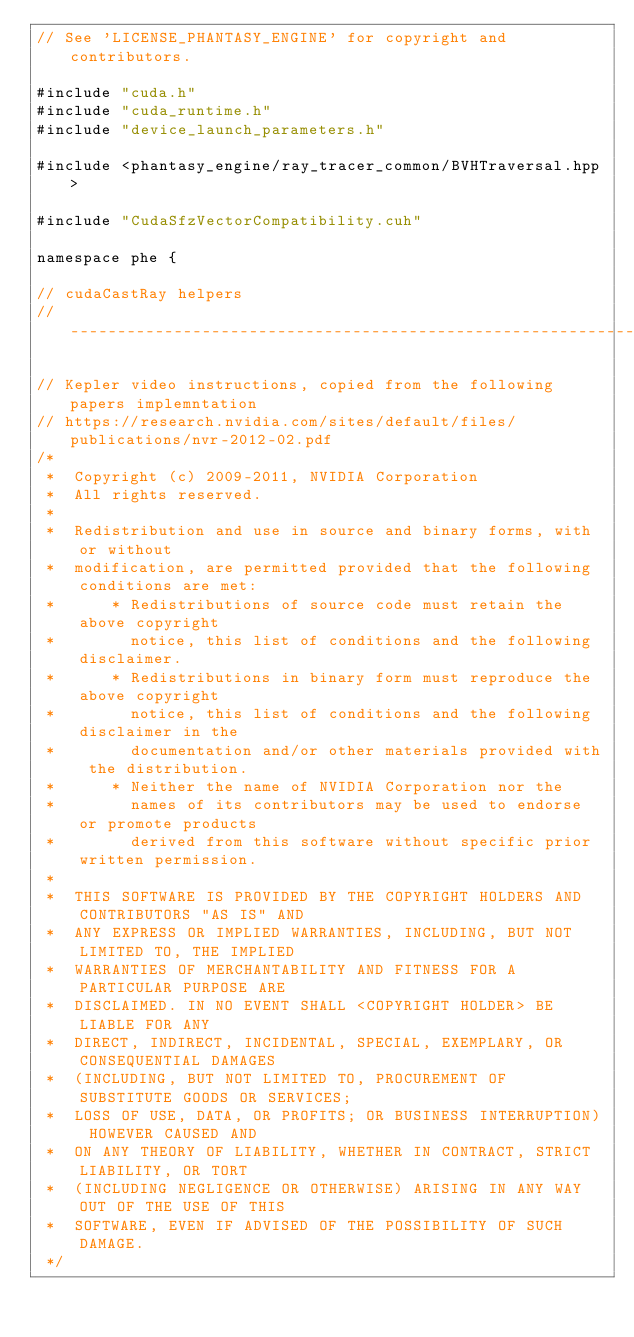<code> <loc_0><loc_0><loc_500><loc_500><_Cuda_>// See 'LICENSE_PHANTASY_ENGINE' for copyright and contributors.

#include "cuda.h"
#include "cuda_runtime.h"
#include "device_launch_parameters.h"

#include <phantasy_engine/ray_tracer_common/BVHTraversal.hpp>

#include "CudaSfzVectorCompatibility.cuh"

namespace phe {

// cudaCastRay helpers
// ------------------------------------------------------------------------------------------------

// Kepler video instructions, copied from the following papers implemntation
// https://research.nvidia.com/sites/default/files/publications/nvr-2012-02.pdf
/*
 *  Copyright (c) 2009-2011, NVIDIA Corporation
 *  All rights reserved.
 *
 *  Redistribution and use in source and binary forms, with or without
 *  modification, are permitted provided that the following conditions are met:
 *      * Redistributions of source code must retain the above copyright
 *        notice, this list of conditions and the following disclaimer.
 *      * Redistributions in binary form must reproduce the above copyright
 *        notice, this list of conditions and the following disclaimer in the
 *        documentation and/or other materials provided with the distribution.
 *      * Neither the name of NVIDIA Corporation nor the
 *        names of its contributors may be used to endorse or promote products
 *        derived from this software without specific prior written permission.
 *
 *  THIS SOFTWARE IS PROVIDED BY THE COPYRIGHT HOLDERS AND CONTRIBUTORS "AS IS" AND
 *  ANY EXPRESS OR IMPLIED WARRANTIES, INCLUDING, BUT NOT LIMITED TO, THE IMPLIED
 *  WARRANTIES OF MERCHANTABILITY AND FITNESS FOR A PARTICULAR PURPOSE ARE
 *  DISCLAIMED. IN NO EVENT SHALL <COPYRIGHT HOLDER> BE LIABLE FOR ANY
 *  DIRECT, INDIRECT, INCIDENTAL, SPECIAL, EXEMPLARY, OR CONSEQUENTIAL DAMAGES
 *  (INCLUDING, BUT NOT LIMITED TO, PROCUREMENT OF SUBSTITUTE GOODS OR SERVICES;
 *  LOSS OF USE, DATA, OR PROFITS; OR BUSINESS INTERRUPTION) HOWEVER CAUSED AND
 *  ON ANY THEORY OF LIABILITY, WHETHER IN CONTRACT, STRICT LIABILITY, OR TORT
 *  (INCLUDING NEGLIGENCE OR OTHERWISE) ARISING IN ANY WAY OUT OF THE USE OF THIS
 *  SOFTWARE, EVEN IF ADVISED OF THE POSSIBILITY OF SUCH DAMAGE.
 */</code> 